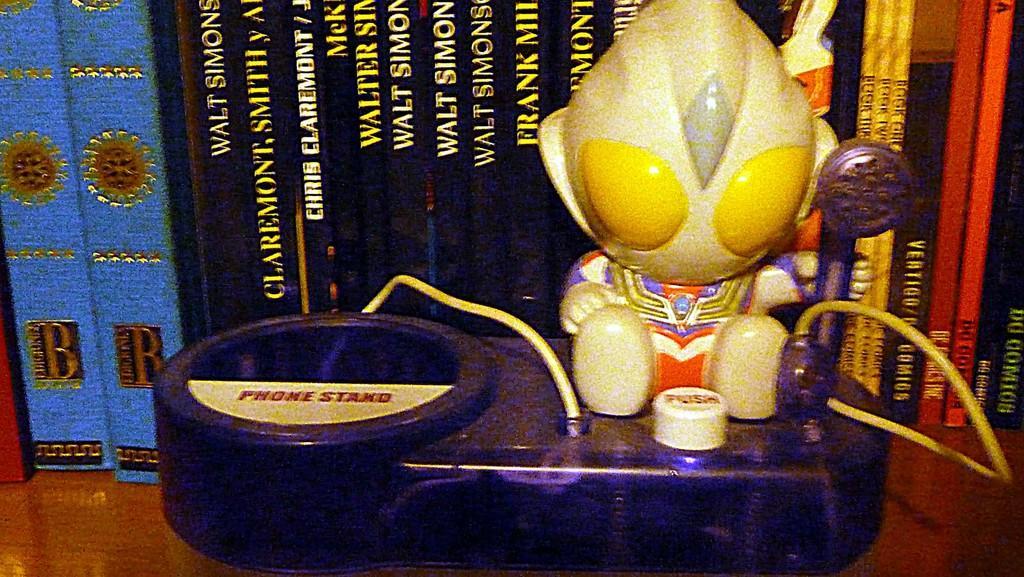In one or two sentences, can you explain what this image depicts? This image consists of a toy. In the background, there are books. It looks like a rack. 